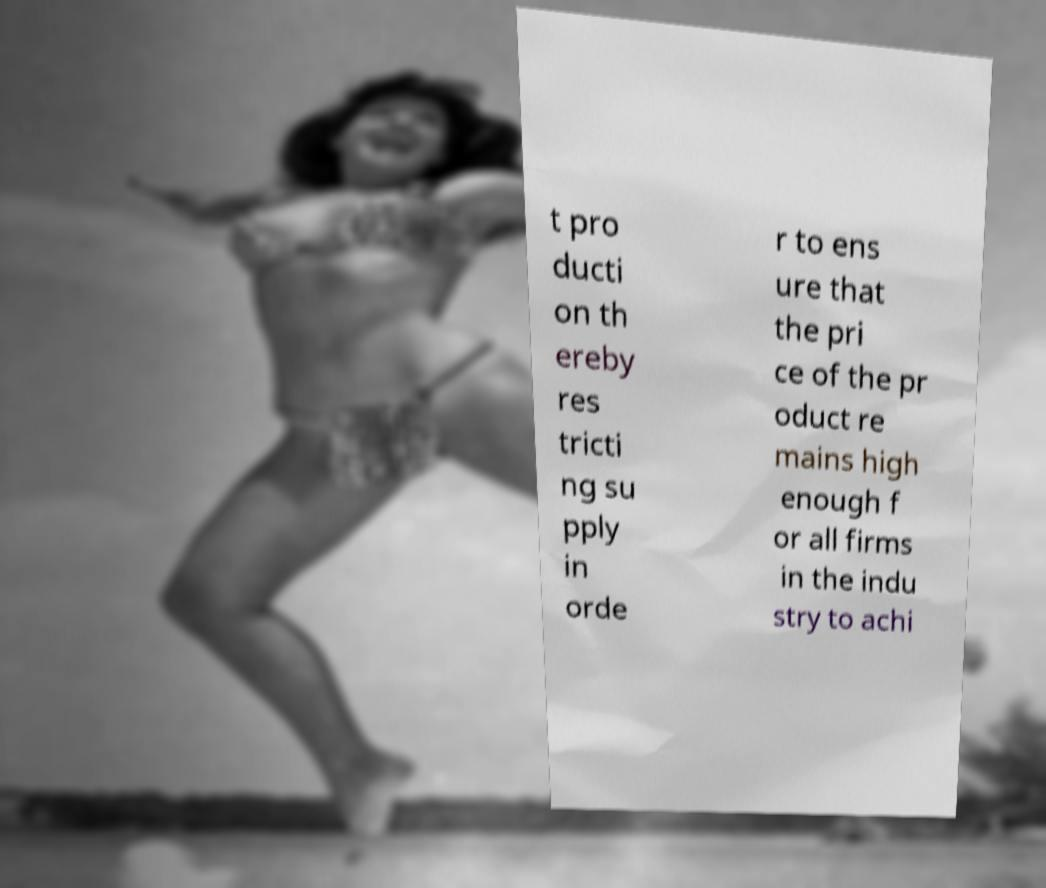There's text embedded in this image that I need extracted. Can you transcribe it verbatim? t pro ducti on th ereby res tricti ng su pply in orde r to ens ure that the pri ce of the pr oduct re mains high enough f or all firms in the indu stry to achi 